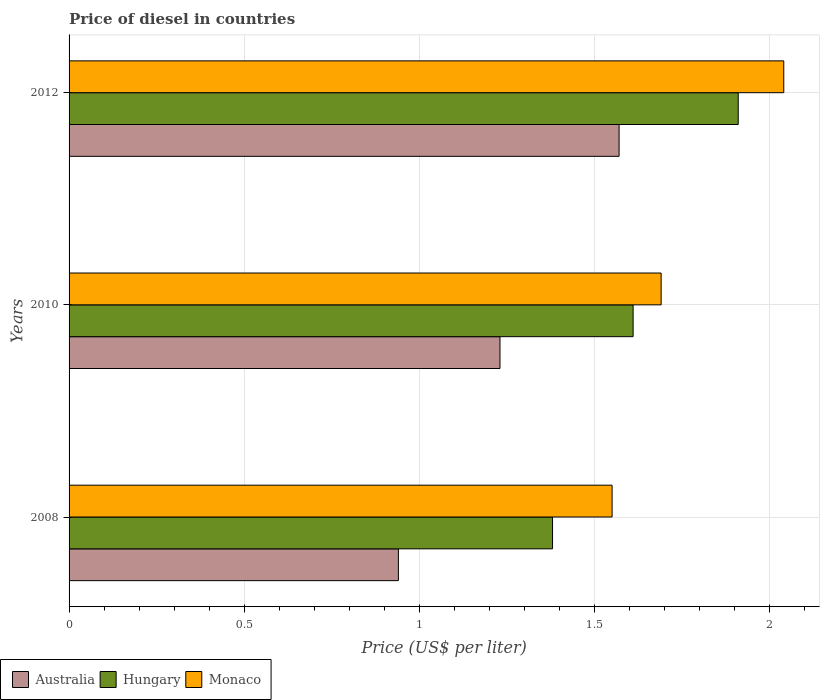How many different coloured bars are there?
Ensure brevity in your answer.  3. Are the number of bars per tick equal to the number of legend labels?
Make the answer very short. Yes. Are the number of bars on each tick of the Y-axis equal?
Keep it short and to the point. Yes. How many bars are there on the 2nd tick from the top?
Offer a terse response. 3. How many bars are there on the 3rd tick from the bottom?
Give a very brief answer. 3. What is the price of diesel in Monaco in 2012?
Make the answer very short. 2.04. Across all years, what is the maximum price of diesel in Hungary?
Your answer should be compact. 1.91. Across all years, what is the minimum price of diesel in Hungary?
Your answer should be very brief. 1.38. In which year was the price of diesel in Hungary maximum?
Keep it short and to the point. 2012. What is the total price of diesel in Australia in the graph?
Your answer should be very brief. 3.74. What is the difference between the price of diesel in Australia in 2008 and that in 2010?
Offer a very short reply. -0.29. What is the difference between the price of diesel in Australia in 2010 and the price of diesel in Hungary in 2008?
Ensure brevity in your answer.  -0.15. What is the average price of diesel in Hungary per year?
Keep it short and to the point. 1.63. In the year 2008, what is the difference between the price of diesel in Monaco and price of diesel in Hungary?
Keep it short and to the point. 0.17. What is the ratio of the price of diesel in Hungary in 2010 to that in 2012?
Give a very brief answer. 0.84. Is the price of diesel in Monaco in 2008 less than that in 2010?
Make the answer very short. Yes. What is the difference between the highest and the second highest price of diesel in Hungary?
Offer a very short reply. 0.3. What is the difference between the highest and the lowest price of diesel in Hungary?
Your answer should be very brief. 0.53. What does the 1st bar from the top in 2012 represents?
Ensure brevity in your answer.  Monaco. What does the 3rd bar from the bottom in 2012 represents?
Provide a succinct answer. Monaco. Are all the bars in the graph horizontal?
Give a very brief answer. Yes. How many years are there in the graph?
Offer a very short reply. 3. Are the values on the major ticks of X-axis written in scientific E-notation?
Make the answer very short. No. How many legend labels are there?
Your response must be concise. 3. How are the legend labels stacked?
Make the answer very short. Horizontal. What is the title of the graph?
Your answer should be very brief. Price of diesel in countries. Does "Singapore" appear as one of the legend labels in the graph?
Make the answer very short. No. What is the label or title of the X-axis?
Keep it short and to the point. Price (US$ per liter). What is the Price (US$ per liter) of Australia in 2008?
Ensure brevity in your answer.  0.94. What is the Price (US$ per liter) in Hungary in 2008?
Make the answer very short. 1.38. What is the Price (US$ per liter) in Monaco in 2008?
Provide a short and direct response. 1.55. What is the Price (US$ per liter) of Australia in 2010?
Your response must be concise. 1.23. What is the Price (US$ per liter) in Hungary in 2010?
Give a very brief answer. 1.61. What is the Price (US$ per liter) in Monaco in 2010?
Keep it short and to the point. 1.69. What is the Price (US$ per liter) of Australia in 2012?
Your answer should be compact. 1.57. What is the Price (US$ per liter) of Hungary in 2012?
Make the answer very short. 1.91. What is the Price (US$ per liter) of Monaco in 2012?
Provide a succinct answer. 2.04. Across all years, what is the maximum Price (US$ per liter) of Australia?
Make the answer very short. 1.57. Across all years, what is the maximum Price (US$ per liter) of Hungary?
Provide a succinct answer. 1.91. Across all years, what is the maximum Price (US$ per liter) of Monaco?
Keep it short and to the point. 2.04. Across all years, what is the minimum Price (US$ per liter) in Hungary?
Offer a very short reply. 1.38. Across all years, what is the minimum Price (US$ per liter) in Monaco?
Offer a terse response. 1.55. What is the total Price (US$ per liter) of Australia in the graph?
Your answer should be very brief. 3.74. What is the total Price (US$ per liter) of Hungary in the graph?
Your answer should be compact. 4.9. What is the total Price (US$ per liter) in Monaco in the graph?
Offer a terse response. 5.28. What is the difference between the Price (US$ per liter) of Australia in 2008 and that in 2010?
Your response must be concise. -0.29. What is the difference between the Price (US$ per liter) of Hungary in 2008 and that in 2010?
Keep it short and to the point. -0.23. What is the difference between the Price (US$ per liter) of Monaco in 2008 and that in 2010?
Your answer should be compact. -0.14. What is the difference between the Price (US$ per liter) of Australia in 2008 and that in 2012?
Keep it short and to the point. -0.63. What is the difference between the Price (US$ per liter) of Hungary in 2008 and that in 2012?
Your answer should be compact. -0.53. What is the difference between the Price (US$ per liter) in Monaco in 2008 and that in 2012?
Provide a short and direct response. -0.49. What is the difference between the Price (US$ per liter) of Australia in 2010 and that in 2012?
Offer a terse response. -0.34. What is the difference between the Price (US$ per liter) of Monaco in 2010 and that in 2012?
Your answer should be compact. -0.35. What is the difference between the Price (US$ per liter) of Australia in 2008 and the Price (US$ per liter) of Hungary in 2010?
Keep it short and to the point. -0.67. What is the difference between the Price (US$ per liter) of Australia in 2008 and the Price (US$ per liter) of Monaco in 2010?
Make the answer very short. -0.75. What is the difference between the Price (US$ per liter) of Hungary in 2008 and the Price (US$ per liter) of Monaco in 2010?
Offer a terse response. -0.31. What is the difference between the Price (US$ per liter) of Australia in 2008 and the Price (US$ per liter) of Hungary in 2012?
Your answer should be very brief. -0.97. What is the difference between the Price (US$ per liter) of Australia in 2008 and the Price (US$ per liter) of Monaco in 2012?
Your response must be concise. -1.1. What is the difference between the Price (US$ per liter) in Hungary in 2008 and the Price (US$ per liter) in Monaco in 2012?
Offer a very short reply. -0.66. What is the difference between the Price (US$ per liter) of Australia in 2010 and the Price (US$ per liter) of Hungary in 2012?
Ensure brevity in your answer.  -0.68. What is the difference between the Price (US$ per liter) of Australia in 2010 and the Price (US$ per liter) of Monaco in 2012?
Offer a terse response. -0.81. What is the difference between the Price (US$ per liter) of Hungary in 2010 and the Price (US$ per liter) of Monaco in 2012?
Provide a succinct answer. -0.43. What is the average Price (US$ per liter) in Australia per year?
Ensure brevity in your answer.  1.25. What is the average Price (US$ per liter) in Hungary per year?
Provide a succinct answer. 1.63. What is the average Price (US$ per liter) of Monaco per year?
Provide a short and direct response. 1.76. In the year 2008, what is the difference between the Price (US$ per liter) in Australia and Price (US$ per liter) in Hungary?
Ensure brevity in your answer.  -0.44. In the year 2008, what is the difference between the Price (US$ per liter) in Australia and Price (US$ per liter) in Monaco?
Make the answer very short. -0.61. In the year 2008, what is the difference between the Price (US$ per liter) in Hungary and Price (US$ per liter) in Monaco?
Your answer should be compact. -0.17. In the year 2010, what is the difference between the Price (US$ per liter) in Australia and Price (US$ per liter) in Hungary?
Offer a very short reply. -0.38. In the year 2010, what is the difference between the Price (US$ per liter) of Australia and Price (US$ per liter) of Monaco?
Your response must be concise. -0.46. In the year 2010, what is the difference between the Price (US$ per liter) in Hungary and Price (US$ per liter) in Monaco?
Provide a succinct answer. -0.08. In the year 2012, what is the difference between the Price (US$ per liter) of Australia and Price (US$ per liter) of Hungary?
Offer a very short reply. -0.34. In the year 2012, what is the difference between the Price (US$ per liter) in Australia and Price (US$ per liter) in Monaco?
Your answer should be very brief. -0.47. In the year 2012, what is the difference between the Price (US$ per liter) of Hungary and Price (US$ per liter) of Monaco?
Give a very brief answer. -0.13. What is the ratio of the Price (US$ per liter) of Australia in 2008 to that in 2010?
Give a very brief answer. 0.76. What is the ratio of the Price (US$ per liter) in Monaco in 2008 to that in 2010?
Offer a very short reply. 0.92. What is the ratio of the Price (US$ per liter) of Australia in 2008 to that in 2012?
Your answer should be very brief. 0.6. What is the ratio of the Price (US$ per liter) in Hungary in 2008 to that in 2012?
Offer a very short reply. 0.72. What is the ratio of the Price (US$ per liter) of Monaco in 2008 to that in 2012?
Offer a terse response. 0.76. What is the ratio of the Price (US$ per liter) of Australia in 2010 to that in 2012?
Your answer should be very brief. 0.78. What is the ratio of the Price (US$ per liter) of Hungary in 2010 to that in 2012?
Offer a terse response. 0.84. What is the ratio of the Price (US$ per liter) in Monaco in 2010 to that in 2012?
Ensure brevity in your answer.  0.83. What is the difference between the highest and the second highest Price (US$ per liter) of Australia?
Ensure brevity in your answer.  0.34. What is the difference between the highest and the second highest Price (US$ per liter) of Hungary?
Offer a very short reply. 0.3. What is the difference between the highest and the second highest Price (US$ per liter) of Monaco?
Your answer should be very brief. 0.35. What is the difference between the highest and the lowest Price (US$ per liter) in Australia?
Your answer should be very brief. 0.63. What is the difference between the highest and the lowest Price (US$ per liter) of Hungary?
Your answer should be compact. 0.53. What is the difference between the highest and the lowest Price (US$ per liter) of Monaco?
Your response must be concise. 0.49. 